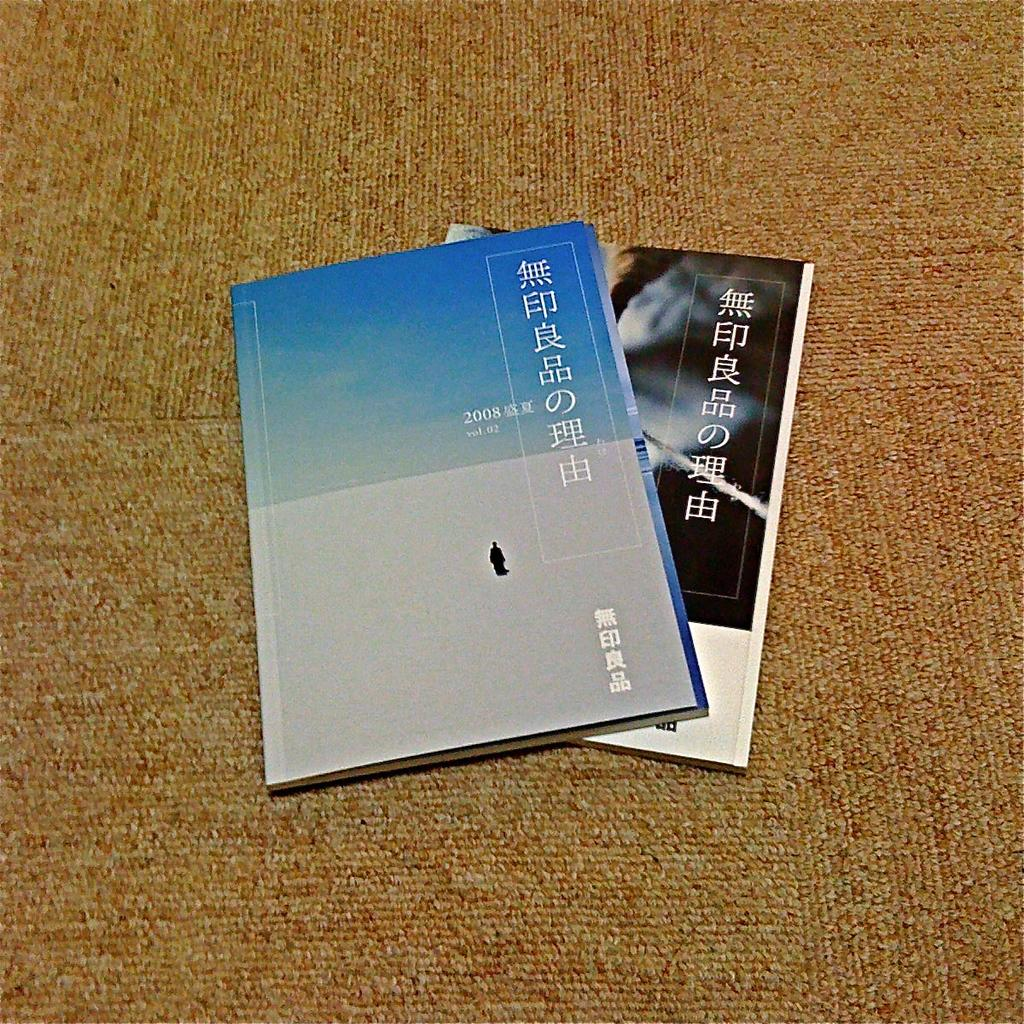<image>
Relay a brief, clear account of the picture shown. A booklet from 2008 is stacked on top of another booklet lying on the carpet. 